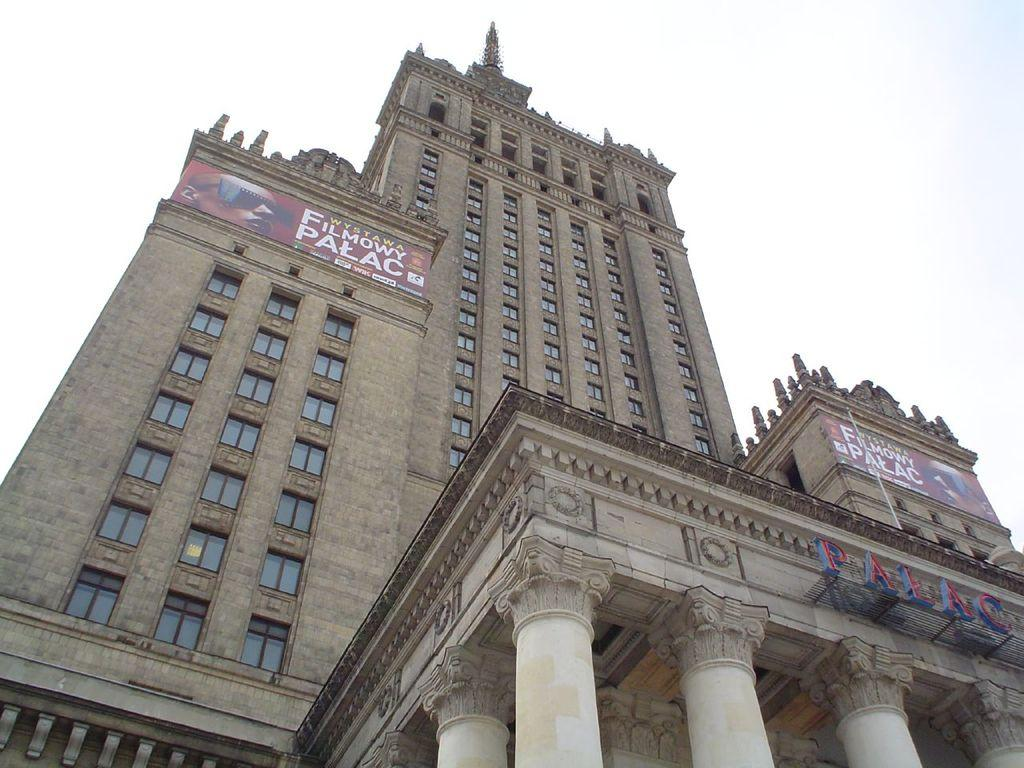What structure is present in the image? There is a building in the image. What is written on the building? There is text written on the building. What is visible at the top of the image? The sky is visible at the top of the image. Where can the cherries be found in the image? There are no cherries present in the image. What type of print is visible on the building? There is no specific print mentioned in the facts; the text written on the building is mentioned, but not its print. 